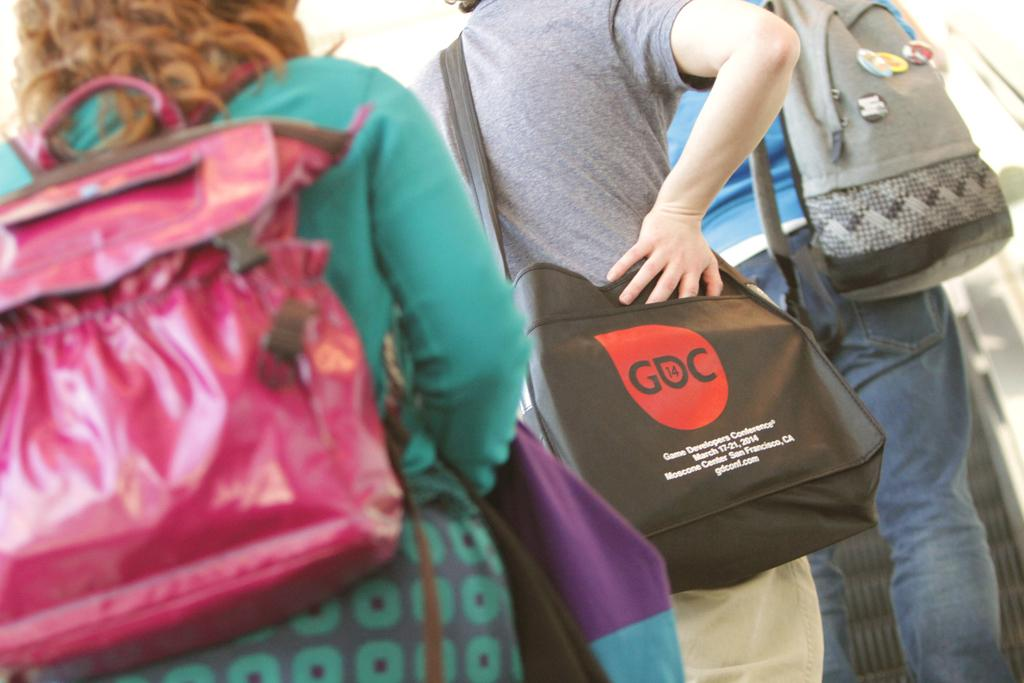How many people are in the image? There are three people in the image. What are the people doing in the image? The people are standing. What are the people wearing that is visible in the image? The people are wearing bags. Are the people in the image sisters? There is no information in the image to suggest that the people are sisters. 